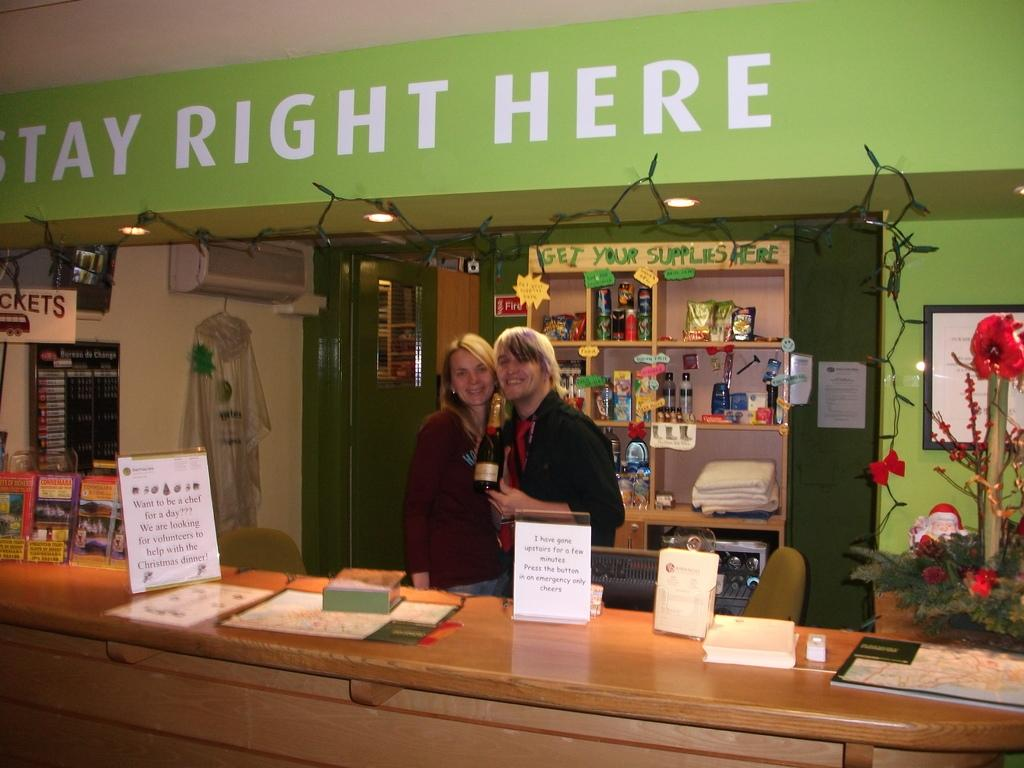How many people are in the image? There are two people in the image. What are the two people doing in the image? The two people are standing together and holding a bottle. What can be seen in the background of the image? There is a grocery store in the background. What is in front of the two people? There is a table in front of the two people. What type of crack is being used to generate ideas in the image? There is no crack or idea generation activity present in the image. 